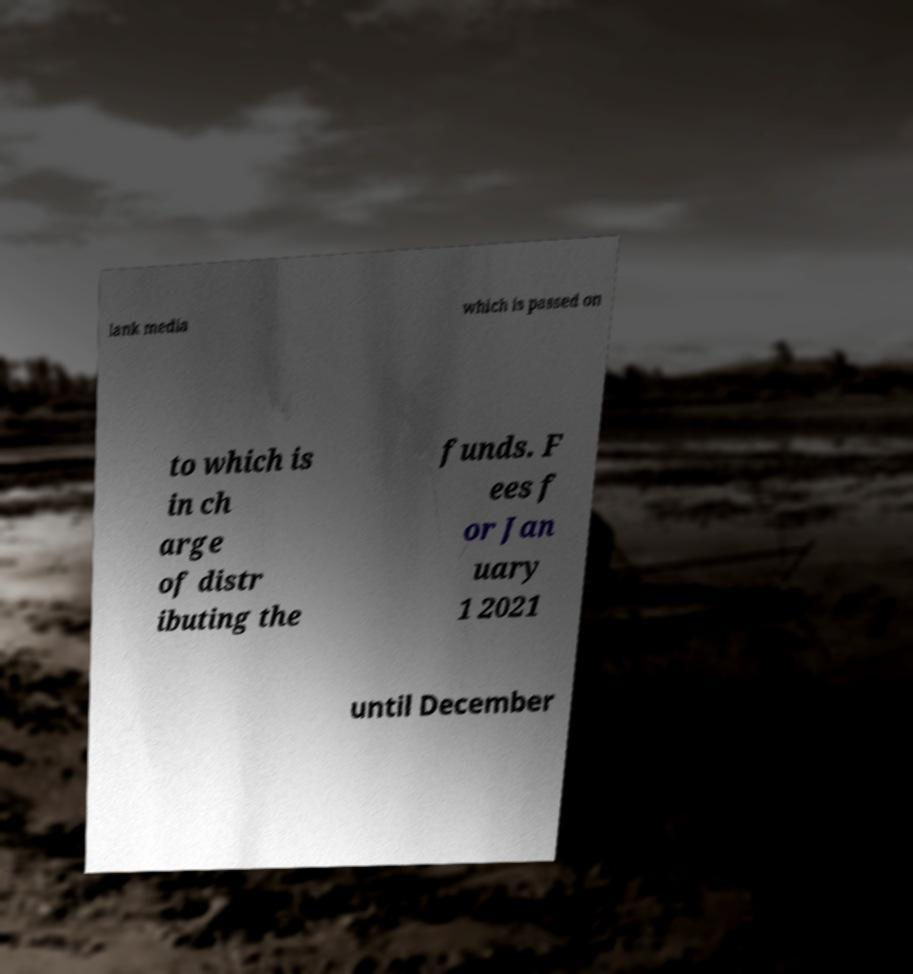What messages or text are displayed in this image? I need them in a readable, typed format. lank media which is passed on to which is in ch arge of distr ibuting the funds. F ees f or Jan uary 1 2021 until December 